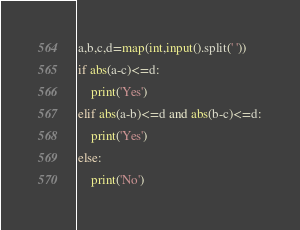Convert code to text. <code><loc_0><loc_0><loc_500><loc_500><_Python_>a,b,c,d=map(int,input().split(' '))
if abs(a-c)<=d:
    print('Yes')
elif abs(a-b)<=d and abs(b-c)<=d:
    print('Yes')
else:
    print('No')
</code> 